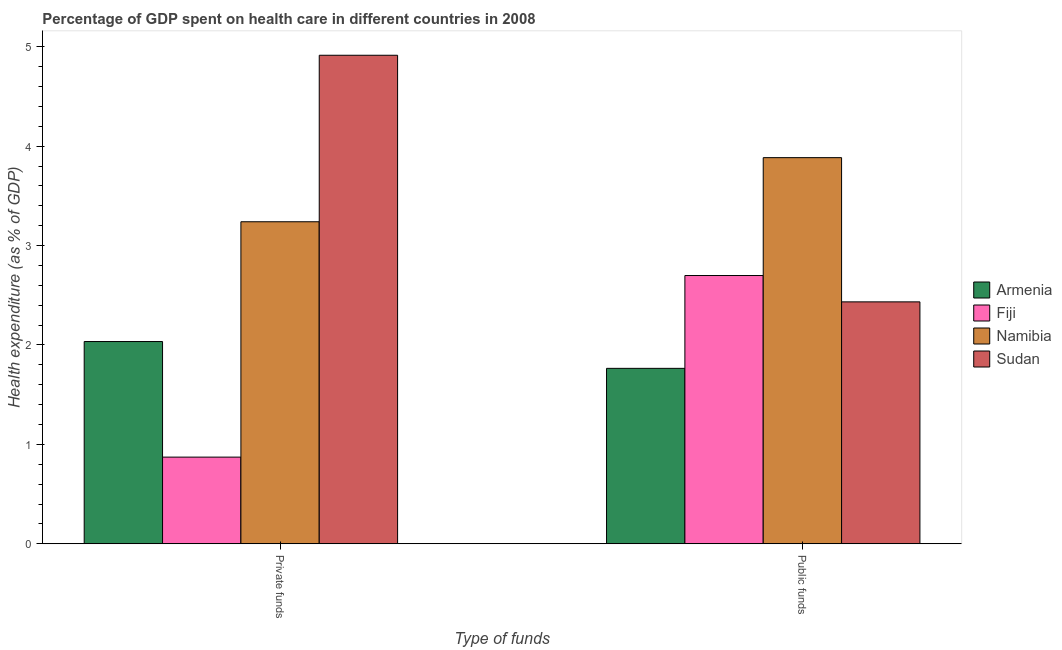Are the number of bars per tick equal to the number of legend labels?
Offer a very short reply. Yes. How many bars are there on the 2nd tick from the left?
Provide a succinct answer. 4. What is the label of the 1st group of bars from the left?
Your response must be concise. Private funds. What is the amount of public funds spent in healthcare in Sudan?
Keep it short and to the point. 2.43. Across all countries, what is the maximum amount of private funds spent in healthcare?
Give a very brief answer. 4.91. Across all countries, what is the minimum amount of private funds spent in healthcare?
Keep it short and to the point. 0.87. In which country was the amount of public funds spent in healthcare maximum?
Ensure brevity in your answer.  Namibia. In which country was the amount of public funds spent in healthcare minimum?
Provide a succinct answer. Armenia. What is the total amount of private funds spent in healthcare in the graph?
Offer a very short reply. 11.06. What is the difference between the amount of public funds spent in healthcare in Namibia and that in Armenia?
Your answer should be compact. 2.12. What is the difference between the amount of private funds spent in healthcare in Namibia and the amount of public funds spent in healthcare in Fiji?
Give a very brief answer. 0.54. What is the average amount of public funds spent in healthcare per country?
Keep it short and to the point. 2.7. What is the difference between the amount of public funds spent in healthcare and amount of private funds spent in healthcare in Armenia?
Offer a very short reply. -0.27. In how many countries, is the amount of public funds spent in healthcare greater than 1.8 %?
Offer a terse response. 3. What is the ratio of the amount of public funds spent in healthcare in Sudan to that in Armenia?
Offer a terse response. 1.38. In how many countries, is the amount of private funds spent in healthcare greater than the average amount of private funds spent in healthcare taken over all countries?
Your answer should be compact. 2. What does the 2nd bar from the left in Private funds represents?
Keep it short and to the point. Fiji. What does the 4th bar from the right in Public funds represents?
Your answer should be compact. Armenia. How many bars are there?
Provide a short and direct response. 8. What is the difference between two consecutive major ticks on the Y-axis?
Ensure brevity in your answer.  1. Are the values on the major ticks of Y-axis written in scientific E-notation?
Keep it short and to the point. No. How many legend labels are there?
Make the answer very short. 4. How are the legend labels stacked?
Ensure brevity in your answer.  Vertical. What is the title of the graph?
Your answer should be compact. Percentage of GDP spent on health care in different countries in 2008. Does "Iran" appear as one of the legend labels in the graph?
Give a very brief answer. No. What is the label or title of the X-axis?
Offer a very short reply. Type of funds. What is the label or title of the Y-axis?
Offer a terse response. Health expenditure (as % of GDP). What is the Health expenditure (as % of GDP) of Armenia in Private funds?
Provide a succinct answer. 2.03. What is the Health expenditure (as % of GDP) of Fiji in Private funds?
Your answer should be compact. 0.87. What is the Health expenditure (as % of GDP) of Namibia in Private funds?
Provide a succinct answer. 3.24. What is the Health expenditure (as % of GDP) in Sudan in Private funds?
Offer a terse response. 4.91. What is the Health expenditure (as % of GDP) of Armenia in Public funds?
Offer a terse response. 1.76. What is the Health expenditure (as % of GDP) of Fiji in Public funds?
Offer a terse response. 2.7. What is the Health expenditure (as % of GDP) of Namibia in Public funds?
Offer a terse response. 3.88. What is the Health expenditure (as % of GDP) of Sudan in Public funds?
Offer a terse response. 2.43. Across all Type of funds, what is the maximum Health expenditure (as % of GDP) of Armenia?
Make the answer very short. 2.03. Across all Type of funds, what is the maximum Health expenditure (as % of GDP) in Fiji?
Your answer should be compact. 2.7. Across all Type of funds, what is the maximum Health expenditure (as % of GDP) of Namibia?
Offer a very short reply. 3.88. Across all Type of funds, what is the maximum Health expenditure (as % of GDP) in Sudan?
Your answer should be very brief. 4.91. Across all Type of funds, what is the minimum Health expenditure (as % of GDP) in Armenia?
Ensure brevity in your answer.  1.76. Across all Type of funds, what is the minimum Health expenditure (as % of GDP) in Fiji?
Your answer should be compact. 0.87. Across all Type of funds, what is the minimum Health expenditure (as % of GDP) of Namibia?
Offer a very short reply. 3.24. Across all Type of funds, what is the minimum Health expenditure (as % of GDP) in Sudan?
Your response must be concise. 2.43. What is the total Health expenditure (as % of GDP) in Armenia in the graph?
Provide a short and direct response. 3.8. What is the total Health expenditure (as % of GDP) of Fiji in the graph?
Make the answer very short. 3.57. What is the total Health expenditure (as % of GDP) of Namibia in the graph?
Offer a terse response. 7.12. What is the total Health expenditure (as % of GDP) of Sudan in the graph?
Provide a short and direct response. 7.35. What is the difference between the Health expenditure (as % of GDP) in Armenia in Private funds and that in Public funds?
Your answer should be very brief. 0.27. What is the difference between the Health expenditure (as % of GDP) in Fiji in Private funds and that in Public funds?
Make the answer very short. -1.83. What is the difference between the Health expenditure (as % of GDP) of Namibia in Private funds and that in Public funds?
Ensure brevity in your answer.  -0.64. What is the difference between the Health expenditure (as % of GDP) in Sudan in Private funds and that in Public funds?
Your answer should be compact. 2.48. What is the difference between the Health expenditure (as % of GDP) in Armenia in Private funds and the Health expenditure (as % of GDP) in Fiji in Public funds?
Your answer should be compact. -0.66. What is the difference between the Health expenditure (as % of GDP) in Armenia in Private funds and the Health expenditure (as % of GDP) in Namibia in Public funds?
Your response must be concise. -1.85. What is the difference between the Health expenditure (as % of GDP) in Armenia in Private funds and the Health expenditure (as % of GDP) in Sudan in Public funds?
Provide a succinct answer. -0.4. What is the difference between the Health expenditure (as % of GDP) in Fiji in Private funds and the Health expenditure (as % of GDP) in Namibia in Public funds?
Provide a succinct answer. -3.01. What is the difference between the Health expenditure (as % of GDP) in Fiji in Private funds and the Health expenditure (as % of GDP) in Sudan in Public funds?
Your answer should be very brief. -1.56. What is the difference between the Health expenditure (as % of GDP) in Namibia in Private funds and the Health expenditure (as % of GDP) in Sudan in Public funds?
Ensure brevity in your answer.  0.81. What is the average Health expenditure (as % of GDP) in Armenia per Type of funds?
Provide a short and direct response. 1.9. What is the average Health expenditure (as % of GDP) in Fiji per Type of funds?
Make the answer very short. 1.79. What is the average Health expenditure (as % of GDP) of Namibia per Type of funds?
Your response must be concise. 3.56. What is the average Health expenditure (as % of GDP) in Sudan per Type of funds?
Offer a terse response. 3.67. What is the difference between the Health expenditure (as % of GDP) in Armenia and Health expenditure (as % of GDP) in Fiji in Private funds?
Your answer should be very brief. 1.16. What is the difference between the Health expenditure (as % of GDP) in Armenia and Health expenditure (as % of GDP) in Namibia in Private funds?
Offer a very short reply. -1.21. What is the difference between the Health expenditure (as % of GDP) in Armenia and Health expenditure (as % of GDP) in Sudan in Private funds?
Provide a short and direct response. -2.88. What is the difference between the Health expenditure (as % of GDP) in Fiji and Health expenditure (as % of GDP) in Namibia in Private funds?
Provide a short and direct response. -2.37. What is the difference between the Health expenditure (as % of GDP) in Fiji and Health expenditure (as % of GDP) in Sudan in Private funds?
Provide a succinct answer. -4.04. What is the difference between the Health expenditure (as % of GDP) of Namibia and Health expenditure (as % of GDP) of Sudan in Private funds?
Provide a succinct answer. -1.67. What is the difference between the Health expenditure (as % of GDP) of Armenia and Health expenditure (as % of GDP) of Fiji in Public funds?
Make the answer very short. -0.93. What is the difference between the Health expenditure (as % of GDP) of Armenia and Health expenditure (as % of GDP) of Namibia in Public funds?
Provide a short and direct response. -2.12. What is the difference between the Health expenditure (as % of GDP) in Armenia and Health expenditure (as % of GDP) in Sudan in Public funds?
Your answer should be very brief. -0.67. What is the difference between the Health expenditure (as % of GDP) of Fiji and Health expenditure (as % of GDP) of Namibia in Public funds?
Ensure brevity in your answer.  -1.19. What is the difference between the Health expenditure (as % of GDP) of Fiji and Health expenditure (as % of GDP) of Sudan in Public funds?
Provide a succinct answer. 0.26. What is the difference between the Health expenditure (as % of GDP) in Namibia and Health expenditure (as % of GDP) in Sudan in Public funds?
Your answer should be very brief. 1.45. What is the ratio of the Health expenditure (as % of GDP) in Armenia in Private funds to that in Public funds?
Keep it short and to the point. 1.15. What is the ratio of the Health expenditure (as % of GDP) in Fiji in Private funds to that in Public funds?
Give a very brief answer. 0.32. What is the ratio of the Health expenditure (as % of GDP) in Namibia in Private funds to that in Public funds?
Provide a succinct answer. 0.83. What is the ratio of the Health expenditure (as % of GDP) in Sudan in Private funds to that in Public funds?
Offer a very short reply. 2.02. What is the difference between the highest and the second highest Health expenditure (as % of GDP) in Armenia?
Keep it short and to the point. 0.27. What is the difference between the highest and the second highest Health expenditure (as % of GDP) of Fiji?
Provide a succinct answer. 1.83. What is the difference between the highest and the second highest Health expenditure (as % of GDP) in Namibia?
Your answer should be compact. 0.64. What is the difference between the highest and the second highest Health expenditure (as % of GDP) of Sudan?
Provide a succinct answer. 2.48. What is the difference between the highest and the lowest Health expenditure (as % of GDP) in Armenia?
Give a very brief answer. 0.27. What is the difference between the highest and the lowest Health expenditure (as % of GDP) in Fiji?
Ensure brevity in your answer.  1.83. What is the difference between the highest and the lowest Health expenditure (as % of GDP) in Namibia?
Offer a terse response. 0.64. What is the difference between the highest and the lowest Health expenditure (as % of GDP) in Sudan?
Your answer should be compact. 2.48. 